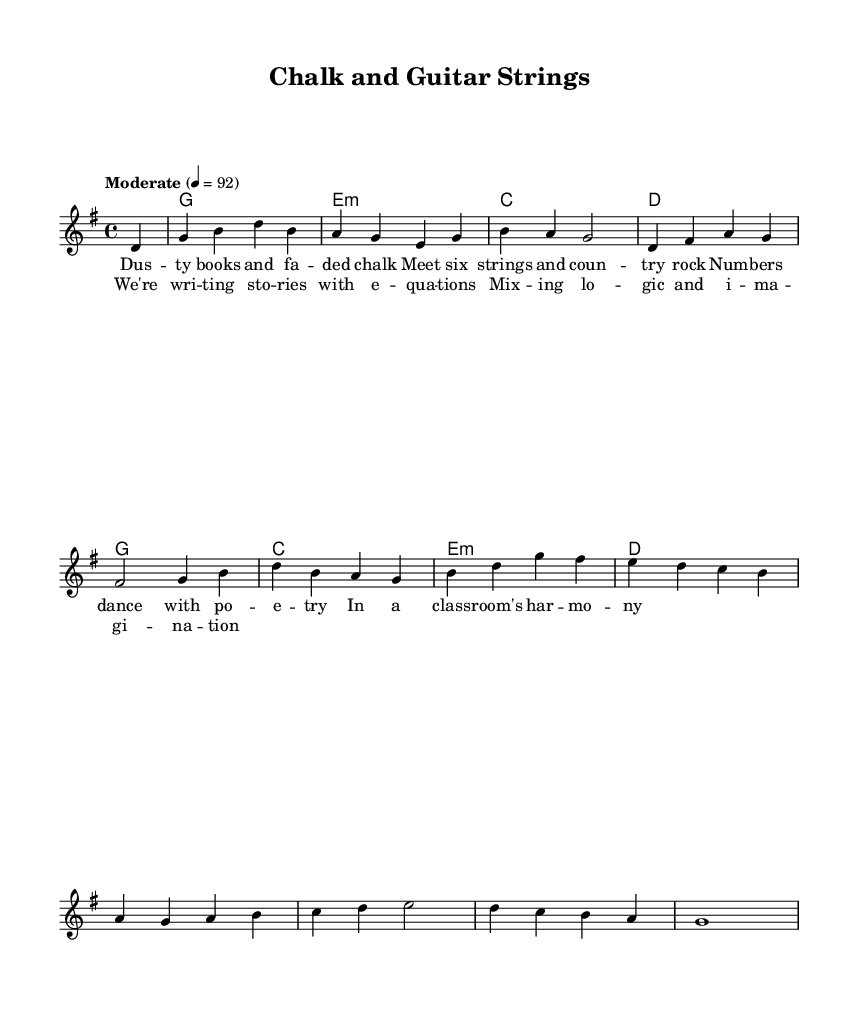What is the key signature of this music? The key signature is G major, indicated by the presence of one sharp (F#) on the staff.
Answer: G major What is the time signature of this music? The time signature is indicated at the beginning of the score, showing 4/4. This means there are four beats in each measure.
Answer: 4/4 What is the tempo marking for this piece? The tempo is indicated as "Moderate" with a metronome marking of 92 beats per minute. This indicates a moderate pace for the music.
Answer: Moderate How many measures are in the melody? By counting the number of bars represented in the melody, we see there are 12 measures total in this section of the score.
Answer: 12 What musical form does the piece follow? The structure consists of verses followed by a chorus, typically found in country rock music. The presence of lyrics in this order suggests a verse-chorus form.
Answer: Verse-Chorus What is the primary theme reflected in the lyrics? The lyrics focus on the interaction between numbers (logic) and poetry (creativity), symbolizing a balance that is fundamental in education, which resonates with the introspective theme of the music.
Answer: Education 